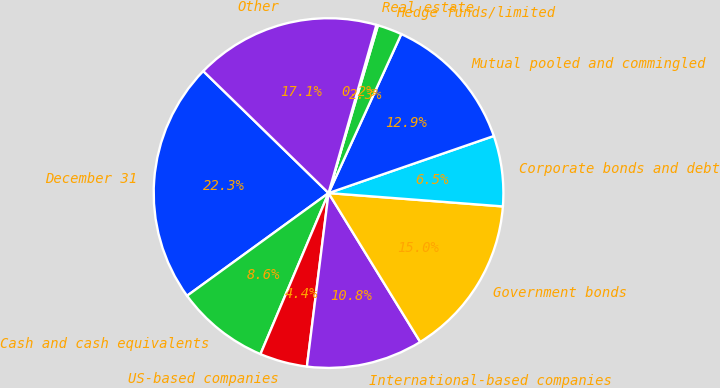<chart> <loc_0><loc_0><loc_500><loc_500><pie_chart><fcel>December 31<fcel>Cash and cash equivalents<fcel>US-based companies<fcel>International-based companies<fcel>Government bonds<fcel>Corporate bonds and debt<fcel>Mutual pooled and commingled<fcel>Hedge funds/limited<fcel>Real estate<fcel>Other<nl><fcel>22.28%<fcel>8.64%<fcel>4.39%<fcel>10.76%<fcel>15.0%<fcel>6.51%<fcel>12.88%<fcel>2.27%<fcel>0.15%<fcel>17.12%<nl></chart> 